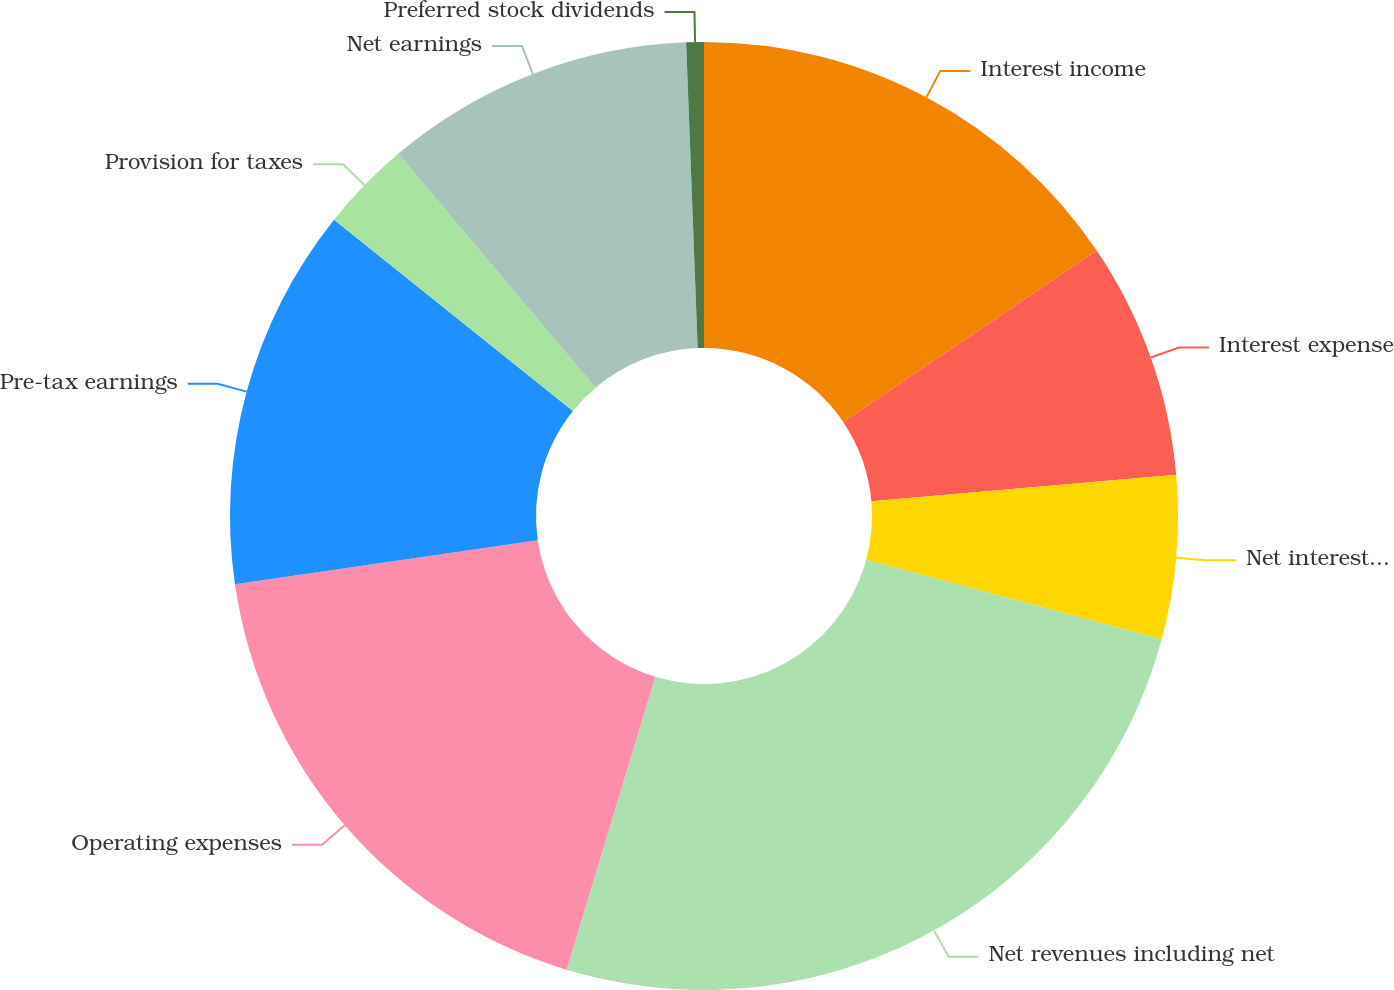Convert chart to OTSL. <chart><loc_0><loc_0><loc_500><loc_500><pie_chart><fcel>Interest income<fcel>Interest expense<fcel>Net interest income<fcel>Net revenues including net<fcel>Operating expenses<fcel>Pre-tax earnings<fcel>Provision for taxes<fcel>Net earnings<fcel>Preferred stock dividends<nl><fcel>15.54%<fcel>8.07%<fcel>5.58%<fcel>25.49%<fcel>18.02%<fcel>13.05%<fcel>3.09%<fcel>10.56%<fcel>0.6%<nl></chart> 